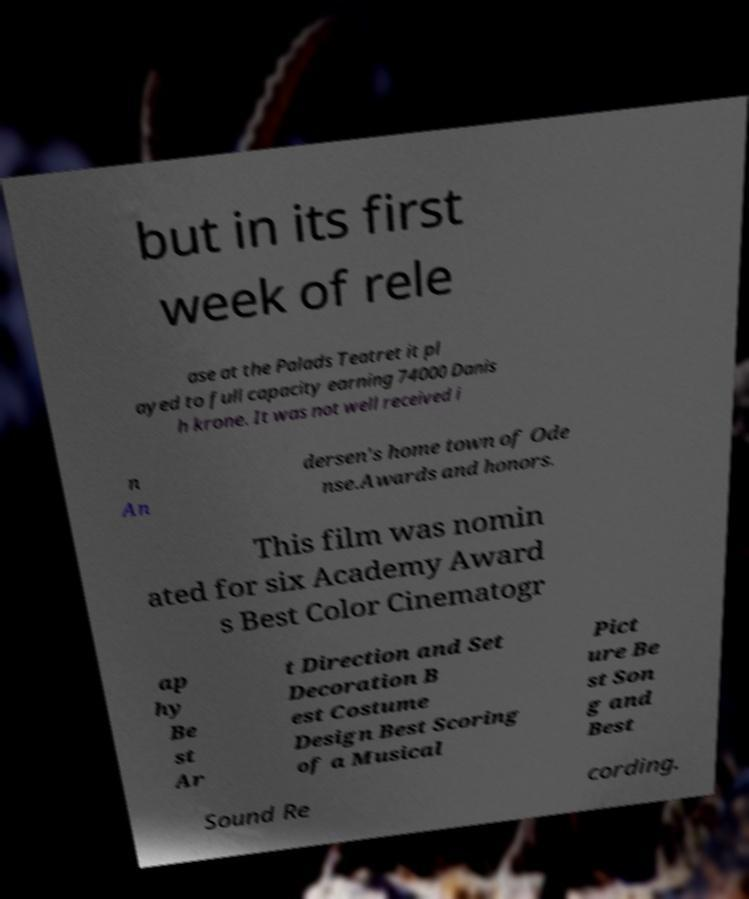Could you assist in decoding the text presented in this image and type it out clearly? but in its first week of rele ase at the Palads Teatret it pl ayed to full capacity earning 74000 Danis h krone. It was not well received i n An dersen's home town of Ode nse.Awards and honors. This film was nomin ated for six Academy Award s Best Color Cinematogr ap hy Be st Ar t Direction and Set Decoration B est Costume Design Best Scoring of a Musical Pict ure Be st Son g and Best Sound Re cording. 